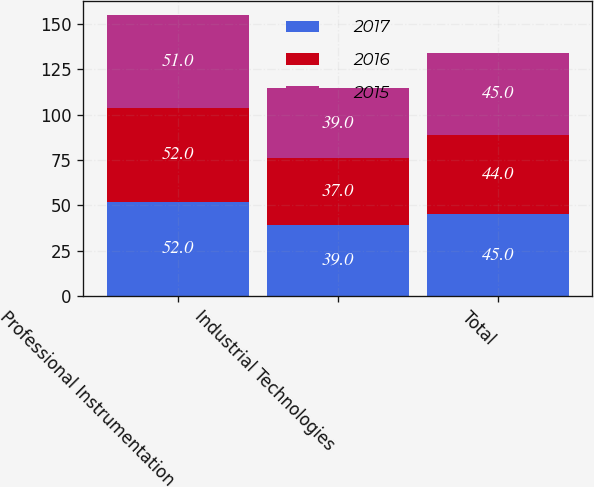Convert chart to OTSL. <chart><loc_0><loc_0><loc_500><loc_500><stacked_bar_chart><ecel><fcel>Professional Instrumentation<fcel>Industrial Technologies<fcel>Total<nl><fcel>2017<fcel>52<fcel>39<fcel>45<nl><fcel>2016<fcel>52<fcel>37<fcel>44<nl><fcel>2015<fcel>51<fcel>39<fcel>45<nl></chart> 